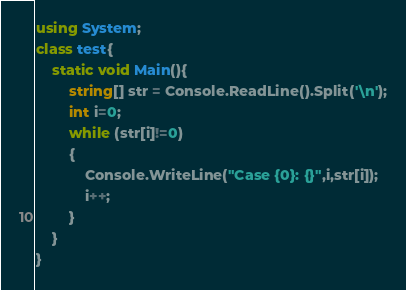Convert code to text. <code><loc_0><loc_0><loc_500><loc_500><_C#_>using System;
class test{
    static void Main(){
        string[] str = Console.ReadLine().Split('\n');
        int i=0;
        while (str[i]!=0)
        {
            Console.WriteLine("Case {0}: {}",i,str[i]);
            i++;
        }
    }
}
</code> 